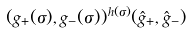Convert formula to latex. <formula><loc_0><loc_0><loc_500><loc_500>( g _ { + } ( \sigma ) , g _ { - } ( \sigma ) ) ^ { h ( \sigma ) } ( { \hat { g } } _ { + } , { \hat { g } } _ { - } )</formula> 